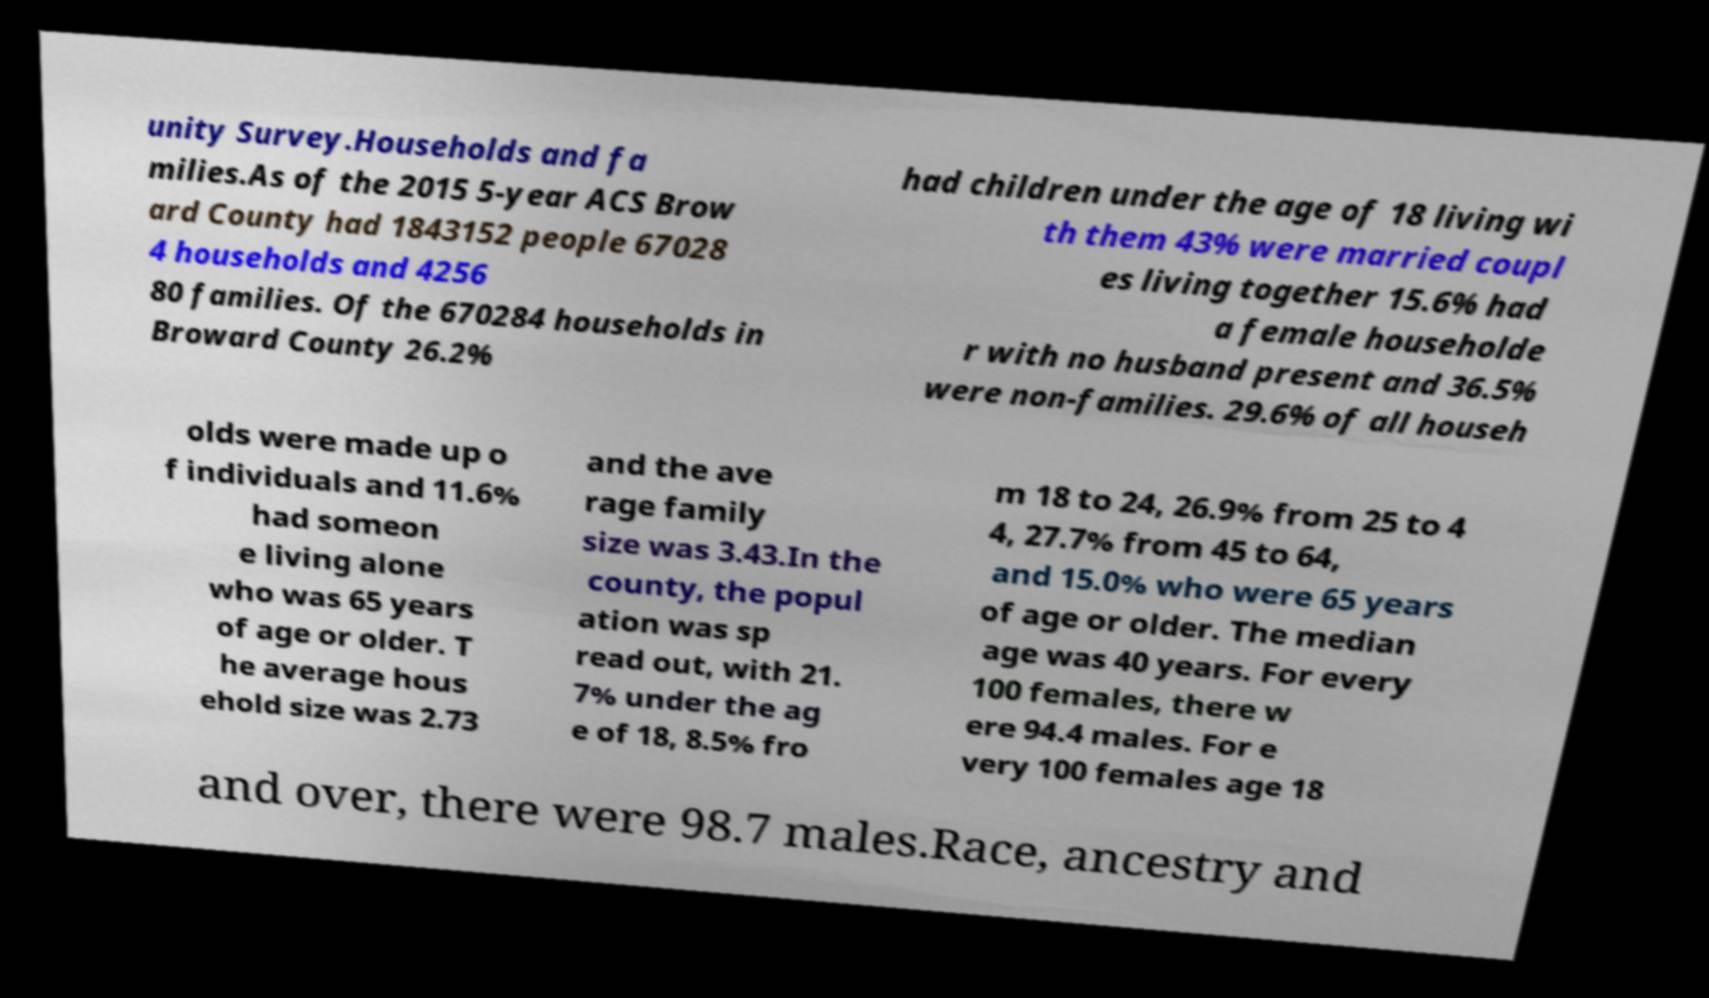Can you read and provide the text displayed in the image?This photo seems to have some interesting text. Can you extract and type it out for me? unity Survey.Households and fa milies.As of the 2015 5-year ACS Brow ard County had 1843152 people 67028 4 households and 4256 80 families. Of the 670284 households in Broward County 26.2% had children under the age of 18 living wi th them 43% were married coupl es living together 15.6% had a female householde r with no husband present and 36.5% were non-families. 29.6% of all househ olds were made up o f individuals and 11.6% had someon e living alone who was 65 years of age or older. T he average hous ehold size was 2.73 and the ave rage family size was 3.43.In the county, the popul ation was sp read out, with 21. 7% under the ag e of 18, 8.5% fro m 18 to 24, 26.9% from 25 to 4 4, 27.7% from 45 to 64, and 15.0% who were 65 years of age or older. The median age was 40 years. For every 100 females, there w ere 94.4 males. For e very 100 females age 18 and over, there were 98.7 males.Race, ancestry and 